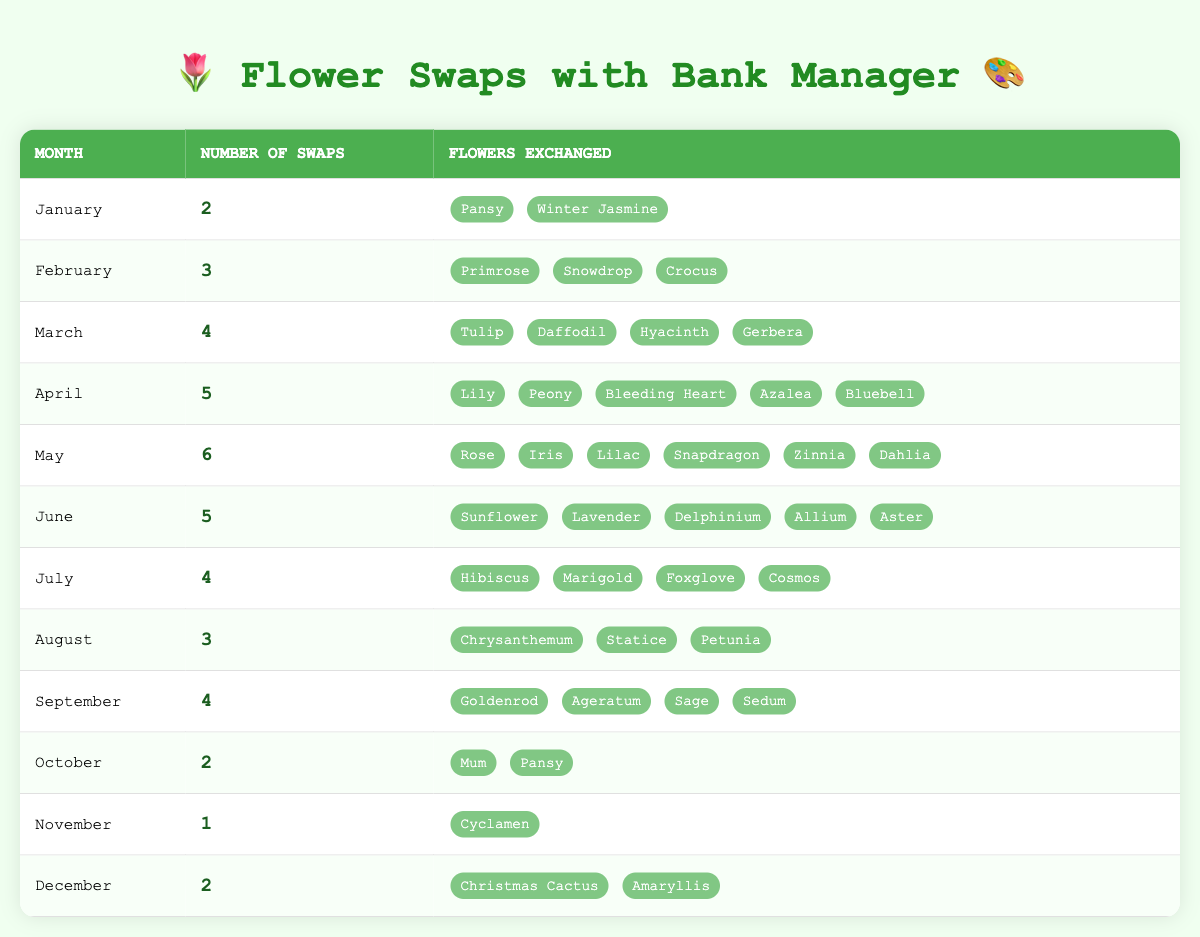What month had the highest number of swaps? Looking at the table, May has the highest number of swaps with a value of 6.
Answer: May How many flower swaps occurred in April? According to the table, April shows a total of 5 swaps.
Answer: 5 In which month were the fewest number of swaps made? By reviewing the table, November had the fewest swaps, with a total of 1 swap.
Answer: November Which month had the most diverse selection of flowers exchanged? April had 5 different flowers exchanged, which is the highest compared to other months, showcasing a diverse selection.
Answer: April What is the total number of swaps made from January to March? The swaps for these months are 2 (January), 3 (February), and 4 (March). Adding them gives a total of 2 + 3 + 4 = 9.
Answer: 9 Did the number of swaps increase in the months leading up to June? By examining the swaps, January to May shows an increasing trend: 2, 3, 4, 5, and 6 respectively, indicating an increase.
Answer: Yes Is the total number of flower swaps in the second half of the year more than in the first half? First half total is 2 (Jan) + 3 (Feb) + 4 (Mar) + 5 (Apr) + 6 (May) + 5 (Jun) = 25. Second half total is 4 (Jul) + 3 (Aug) + 4 (Sep) + 2 (Oct) + 1 (Nov) + 2 (Dec) = 16. Since 25 > 16, so the first half has more swaps.
Answer: No How many unique flowers were exchanged in August? August has a total of 3 different flowers listed: Chrysanthemum, Statice, and Petunia.
Answer: 3 What was the average number of swaps per month from January to December? We need to sum all swaps: 2 + 3 + 4 + 5 + 6 + 5 + 4 + 3 + 4 + 2 + 1 + 2 = 41. There are 12 months, so the average is 41 / 12 ≈ 3.42.
Answer: 3.42 